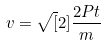Convert formula to latex. <formula><loc_0><loc_0><loc_500><loc_500>v = \sqrt { [ } 2 ] { \frac { 2 P t } { m } }</formula> 